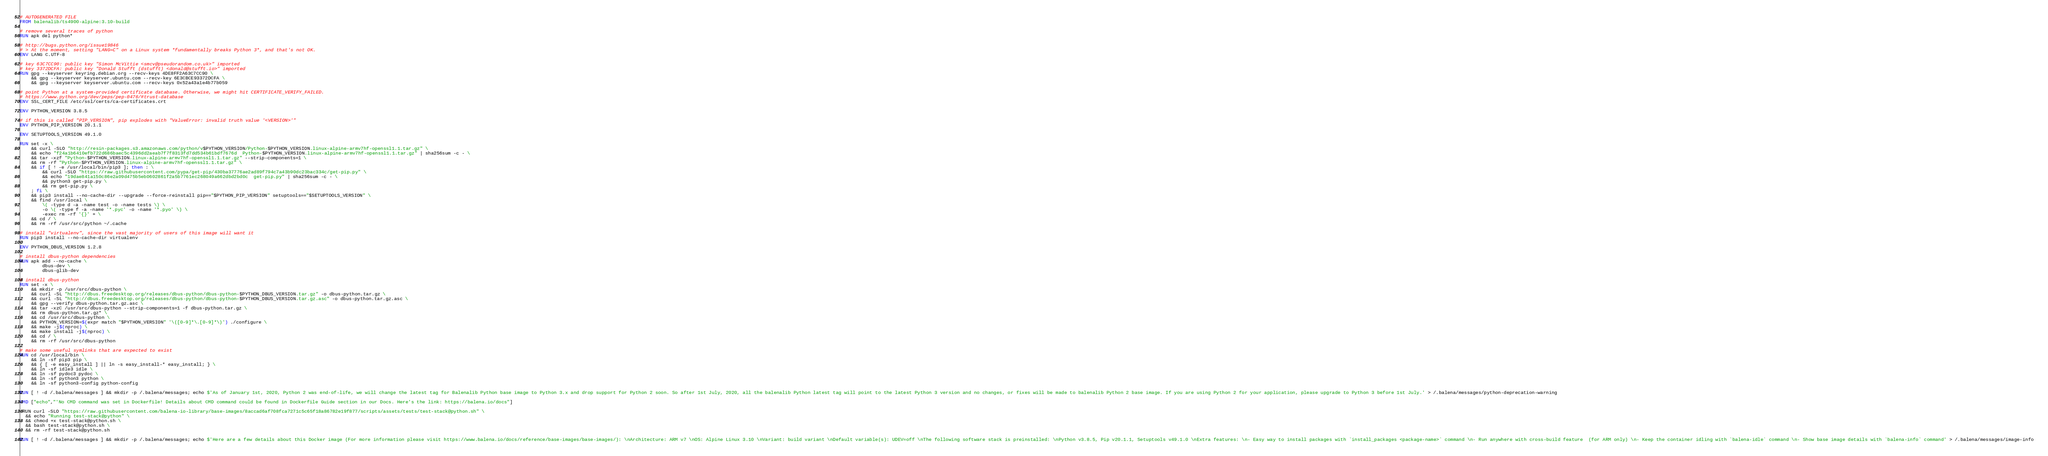<code> <loc_0><loc_0><loc_500><loc_500><_Dockerfile_># AUTOGENERATED FILE
FROM balenalib/ts4900-alpine:3.10-build

# remove several traces of python
RUN apk del python*

# http://bugs.python.org/issue19846
# > At the moment, setting "LANG=C" on a Linux system *fundamentally breaks Python 3*, and that's not OK.
ENV LANG C.UTF-8

# key 63C7CC90: public key "Simon McVittie <smcv@pseudorandom.co.uk>" imported
# key 3372DCFA: public key "Donald Stufft (dstufft) <donald@stufft.io>" imported
RUN gpg --keyserver keyring.debian.org --recv-keys 4DE8FF2A63C7CC90 \
	&& gpg --keyserver keyserver.ubuntu.com --recv-key 6E3CBCE93372DCFA \
	&& gpg --keyserver keyserver.ubuntu.com --recv-keys 0x52a43a1e4b77b059

# point Python at a system-provided certificate database. Otherwise, we might hit CERTIFICATE_VERIFY_FAILED.
# https://www.python.org/dev/peps/pep-0476/#trust-database
ENV SSL_CERT_FILE /etc/ssl/certs/ca-certificates.crt

ENV PYTHON_VERSION 3.8.5

# if this is called "PIP_VERSION", pip explodes with "ValueError: invalid truth value '<VERSION>'"
ENV PYTHON_PIP_VERSION 20.1.1

ENV SETUPTOOLS_VERSION 49.1.0

RUN set -x \
	&& curl -SLO "http://resin-packages.s3.amazonaws.com/python/v$PYTHON_VERSION/Python-$PYTHON_VERSION.linux-alpine-armv7hf-openssl1.1.tar.gz" \
	&& echo "f24a1b6410efb722d686baec5c4396dd2aeab7f7f8313fd7dd534b61bdf7676d  Python-$PYTHON_VERSION.linux-alpine-armv7hf-openssl1.1.tar.gz" | sha256sum -c - \
	&& tar -xzf "Python-$PYTHON_VERSION.linux-alpine-armv7hf-openssl1.1.tar.gz" --strip-components=1 \
	&& rm -rf "Python-$PYTHON_VERSION.linux-alpine-armv7hf-openssl1.1.tar.gz" \
	&& if [ ! -e /usr/local/bin/pip3 ]; then : \
		&& curl -SLO "https://raw.githubusercontent.com/pypa/get-pip/430ba37776ae2ad89f794c7a43b90dc23bac334c/get-pip.py" \
		&& echo "19dae841a150c86e2a09d475b5eb0602861f2a5b7761ec268049a662dbd2bd0c  get-pip.py" | sha256sum -c - \
		&& python3 get-pip.py \
		&& rm get-pip.py \
	; fi \
	&& pip3 install --no-cache-dir --upgrade --force-reinstall pip=="$PYTHON_PIP_VERSION" setuptools=="$SETUPTOOLS_VERSION" \
	&& find /usr/local \
		\( -type d -a -name test -o -name tests \) \
		-o \( -type f -a -name '*.pyc' -o -name '*.pyo' \) \
		-exec rm -rf '{}' + \
	&& cd / \
	&& rm -rf /usr/src/python ~/.cache

# install "virtualenv", since the vast majority of users of this image will want it
RUN pip3 install --no-cache-dir virtualenv

ENV PYTHON_DBUS_VERSION 1.2.8

# install dbus-python dependencies 
RUN apk add --no-cache \
		dbus-dev \
		dbus-glib-dev

# install dbus-python
RUN set -x \
	&& mkdir -p /usr/src/dbus-python \
	&& curl -SL "http://dbus.freedesktop.org/releases/dbus-python/dbus-python-$PYTHON_DBUS_VERSION.tar.gz" -o dbus-python.tar.gz \
	&& curl -SL "http://dbus.freedesktop.org/releases/dbus-python/dbus-python-$PYTHON_DBUS_VERSION.tar.gz.asc" -o dbus-python.tar.gz.asc \
	&& gpg --verify dbus-python.tar.gz.asc \
	&& tar -xzC /usr/src/dbus-python --strip-components=1 -f dbus-python.tar.gz \
	&& rm dbus-python.tar.gz* \
	&& cd /usr/src/dbus-python \
	&& PYTHON_VERSION=$(expr match "$PYTHON_VERSION" '\([0-9]*\.[0-9]*\)') ./configure \
	&& make -j$(nproc) \
	&& make install -j$(nproc) \
	&& cd / \
	&& rm -rf /usr/src/dbus-python

# make some useful symlinks that are expected to exist
RUN cd /usr/local/bin \
	&& ln -sf pip3 pip \
	&& { [ -e easy_install ] || ln -s easy_install-* easy_install; } \
	&& ln -sf idle3 idle \
	&& ln -sf pydoc3 pydoc \
	&& ln -sf python3 python \
	&& ln -sf python3-config python-config

RUN [ ! -d /.balena/messages ] && mkdir -p /.balena/messages; echo $'As of January 1st, 2020, Python 2 was end-of-life, we will change the latest tag for Balenalib Python base image to Python 3.x and drop support for Python 2 soon. So after 1st July, 2020, all the balenalib Python latest tag will point to the latest Python 3 version and no changes, or fixes will be made to balenalib Python 2 base image. If you are using Python 2 for your application, please upgrade to Python 3 before 1st July.' > /.balena/messages/python-deprecation-warning

CMD ["echo","'No CMD command was set in Dockerfile! Details about CMD command could be found in Dockerfile Guide section in our Docs. Here's the link: https://balena.io/docs"]

 RUN curl -SLO "https://raw.githubusercontent.com/balena-io-library/base-images/8accad6af708fca7271c5c65f18a86782e19f877/scripts/assets/tests/test-stack@python.sh" \
  && echo "Running test-stack@python" \
  && chmod +x test-stack@python.sh \
  && bash test-stack@python.sh \
  && rm -rf test-stack@python.sh 

RUN [ ! -d /.balena/messages ] && mkdir -p /.balena/messages; echo $'Here are a few details about this Docker image (For more information please visit https://www.balena.io/docs/reference/base-images/base-images/): \nArchitecture: ARM v7 \nOS: Alpine Linux 3.10 \nVariant: build variant \nDefault variable(s): UDEV=off \nThe following software stack is preinstalled: \nPython v3.8.5, Pip v20.1.1, Setuptools v49.1.0 \nExtra features: \n- Easy way to install packages with `install_packages <package-name>` command \n- Run anywhere with cross-build feature  (for ARM only) \n- Keep the container idling with `balena-idle` command \n- Show base image details with `balena-info` command' > /.balena/messages/image-info
</code> 